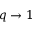<formula> <loc_0><loc_0><loc_500><loc_500>q \to 1</formula> 